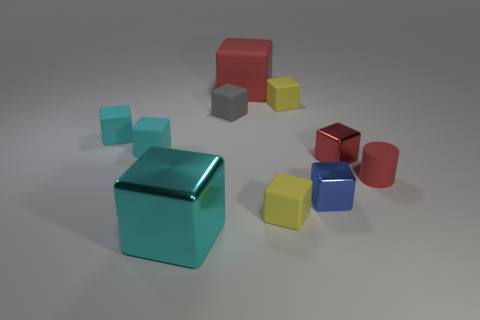Subtract all cyan blocks. How many were subtracted if there are1cyan blocks left? 2 Subtract all green cylinders. How many cyan cubes are left? 3 Subtract 1 cubes. How many cubes are left? 8 Subtract all yellow blocks. How many blocks are left? 7 Subtract all big red cubes. How many cubes are left? 8 Subtract all cyan cubes. Subtract all cyan spheres. How many cubes are left? 6 Subtract all blocks. How many objects are left? 1 Subtract all small gray matte cylinders. Subtract all tiny cyan rubber blocks. How many objects are left? 8 Add 2 cyan cubes. How many cyan cubes are left? 5 Add 10 tiny brown metallic cylinders. How many tiny brown metallic cylinders exist? 10 